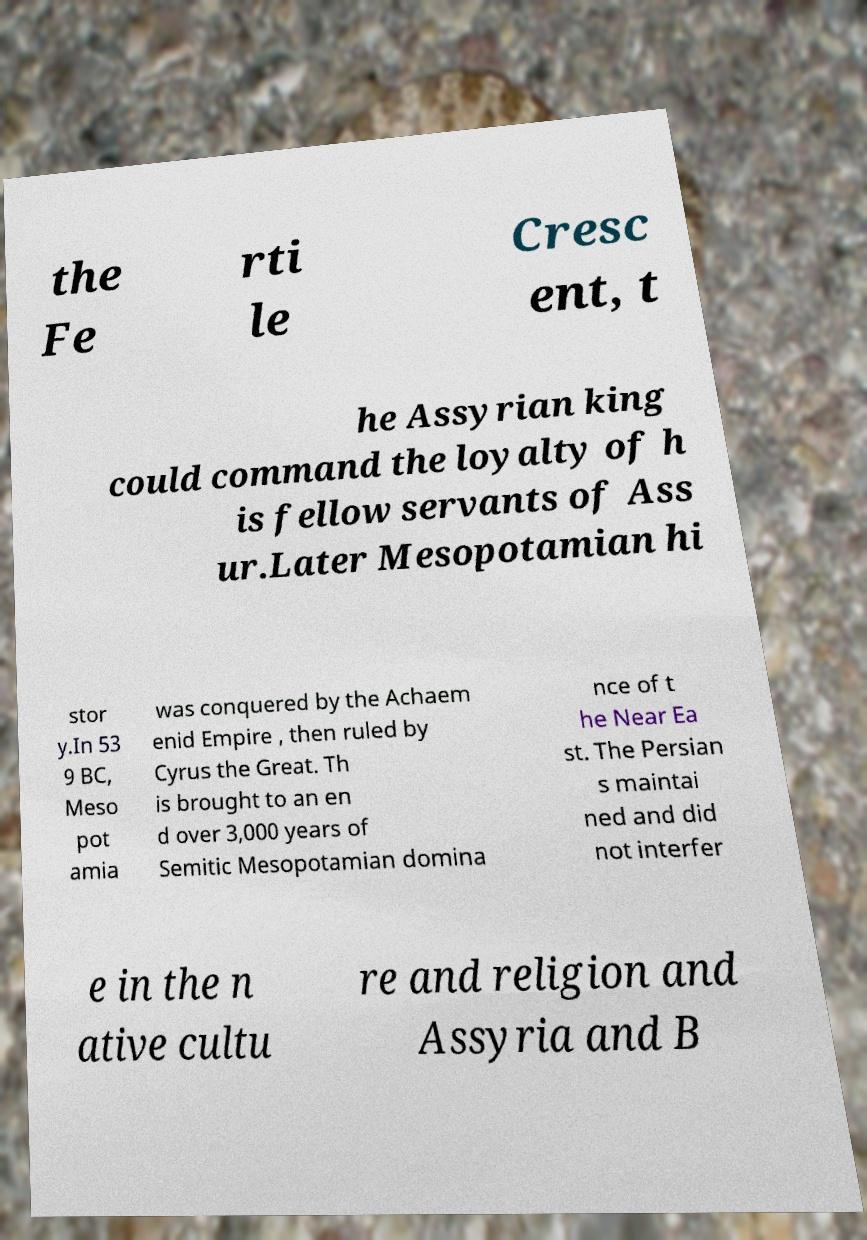Could you extract and type out the text from this image? the Fe rti le Cresc ent, t he Assyrian king could command the loyalty of h is fellow servants of Ass ur.Later Mesopotamian hi stor y.In 53 9 BC, Meso pot amia was conquered by the Achaem enid Empire , then ruled by Cyrus the Great. Th is brought to an en d over 3,000 years of Semitic Mesopotamian domina nce of t he Near Ea st. The Persian s maintai ned and did not interfer e in the n ative cultu re and religion and Assyria and B 